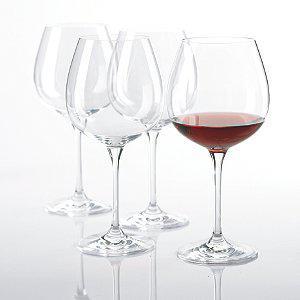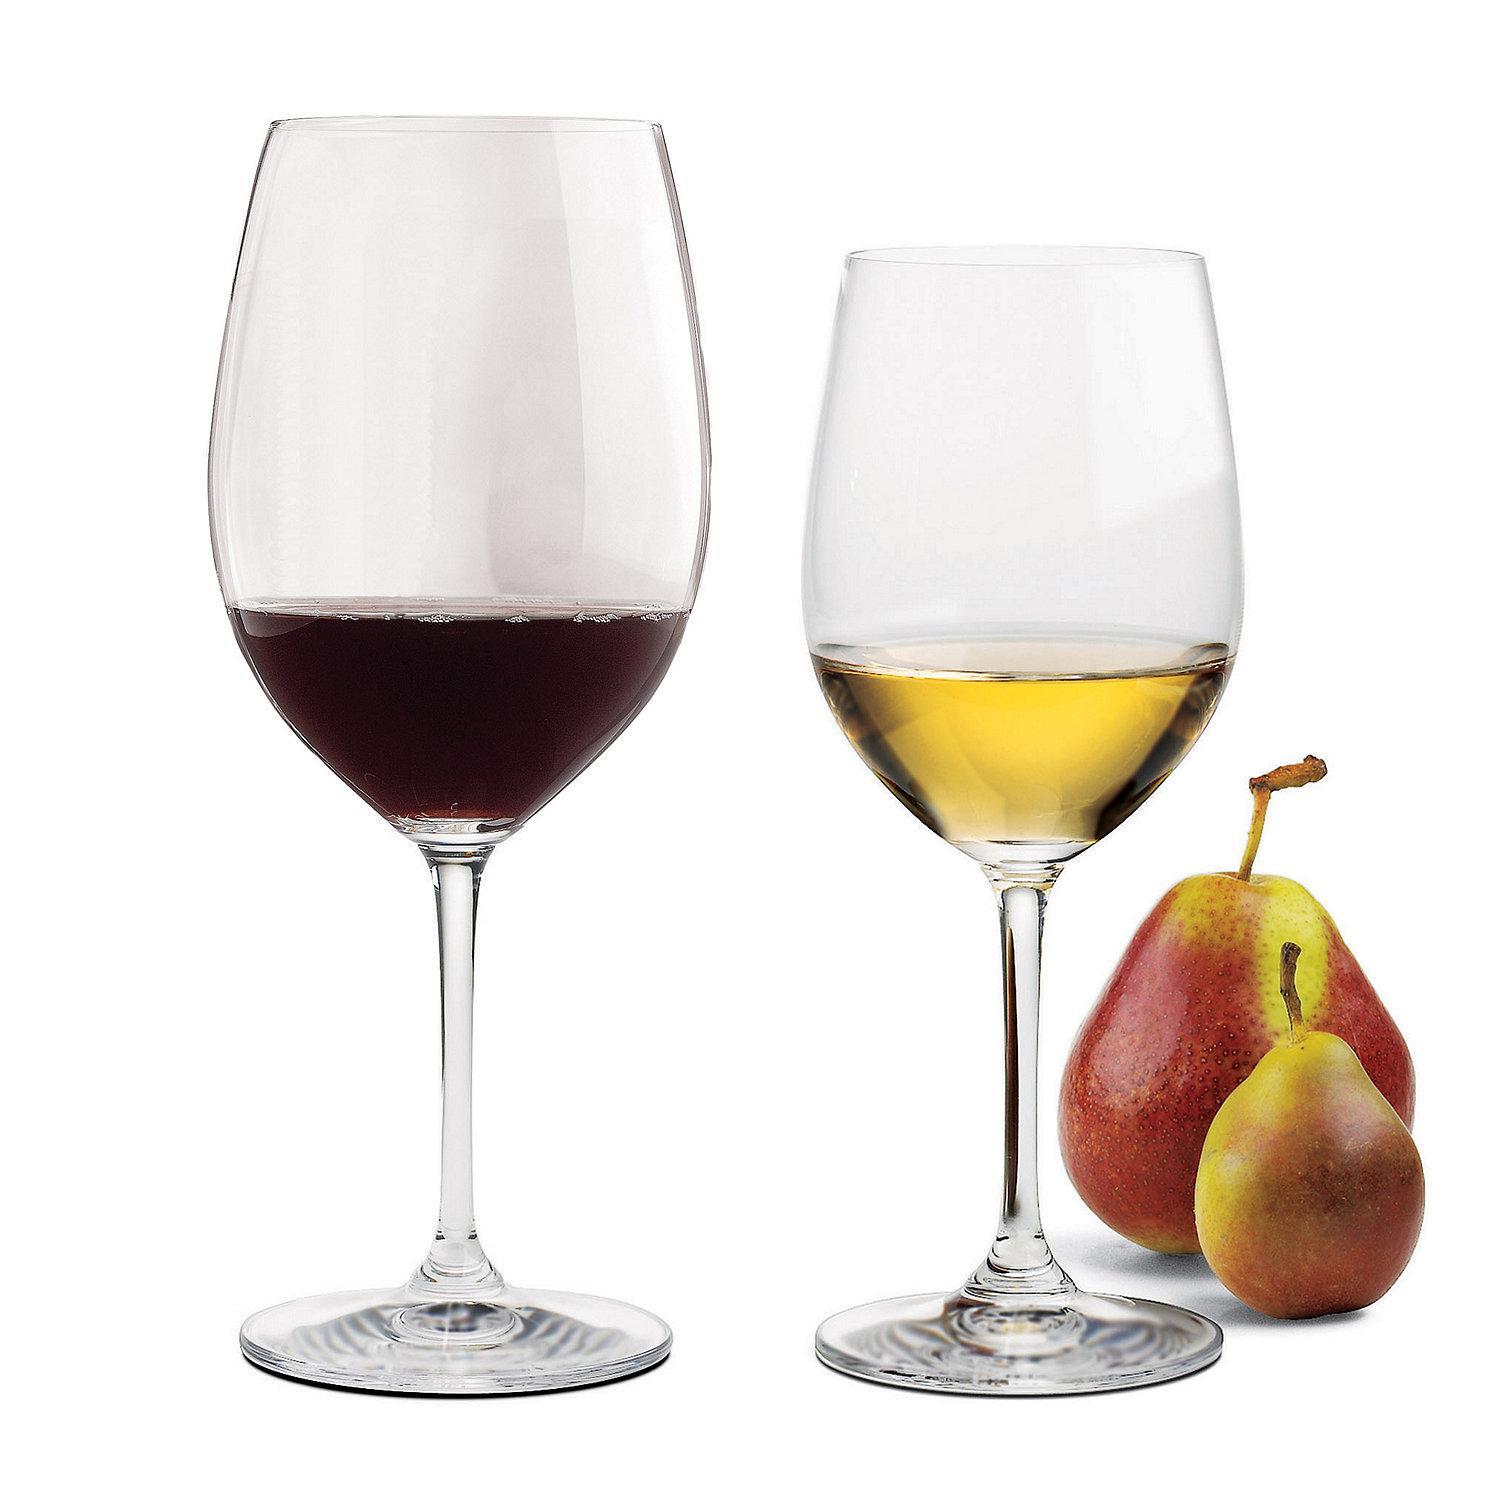The first image is the image on the left, the second image is the image on the right. Assess this claim about the two images: "In one image, two glasses are right next to each other, and in the other, four glasses are arranged so some are in front of others.". Correct or not? Answer yes or no. Yes. The first image is the image on the left, the second image is the image on the right. Considering the images on both sides, is "In the left image, there is one glass of red wine and three empty wine glasses" valid? Answer yes or no. Yes. 